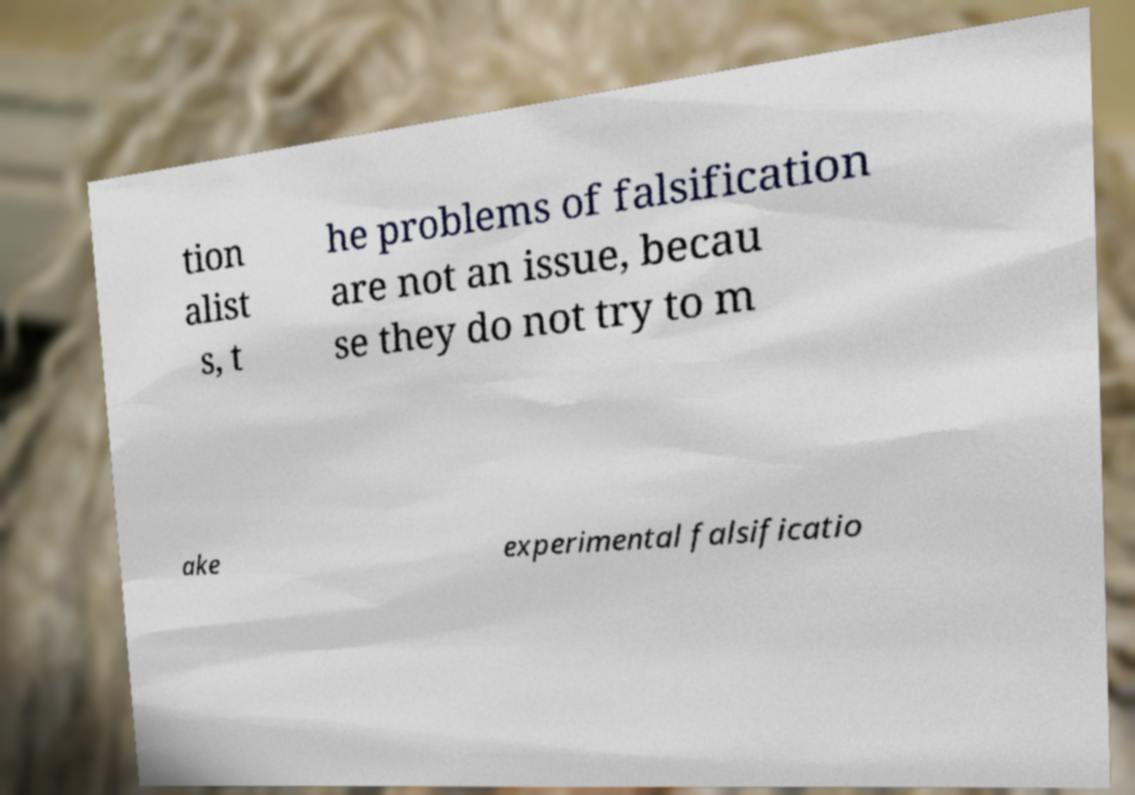I need the written content from this picture converted into text. Can you do that? tion alist s, t he problems of falsification are not an issue, becau se they do not try to m ake experimental falsificatio 